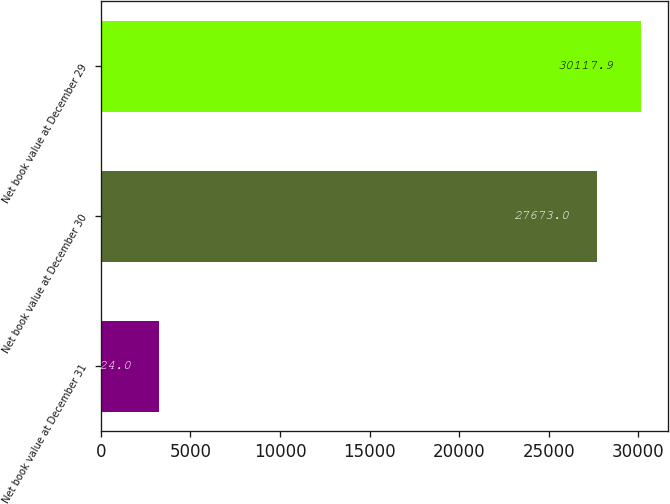Convert chart. <chart><loc_0><loc_0><loc_500><loc_500><bar_chart><fcel>Net book value at December 31<fcel>Net book value at December 30<fcel>Net book value at December 29<nl><fcel>3224<fcel>27673<fcel>30117.9<nl></chart> 